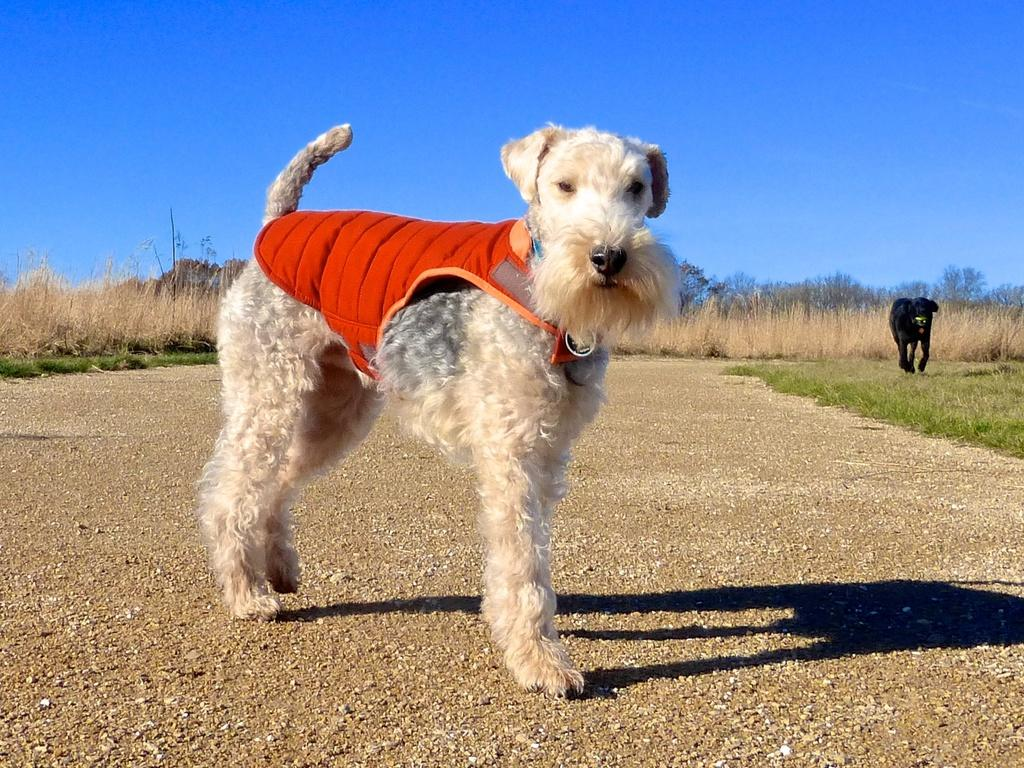What is the main subject in the foreground of the image? There is a dog in the foreground of the image. What type of ground is visible in the foreground of the image? Soil is present in the foreground of the image. What can be seen in the middle of the image? There are plants, grass, trees, and other objects in the middle of the image. Where is the dog located in the image? The dog is also in the middle of the image. What is visible at the top of the image? The sky is visible at the top of the image. What type of lettuce is being used to draw on the sidewalk in the image? There is no lettuce or drawing on the sidewalk present in the image. How many pets are visible in the image? The image only features one pet, which is the dog. 